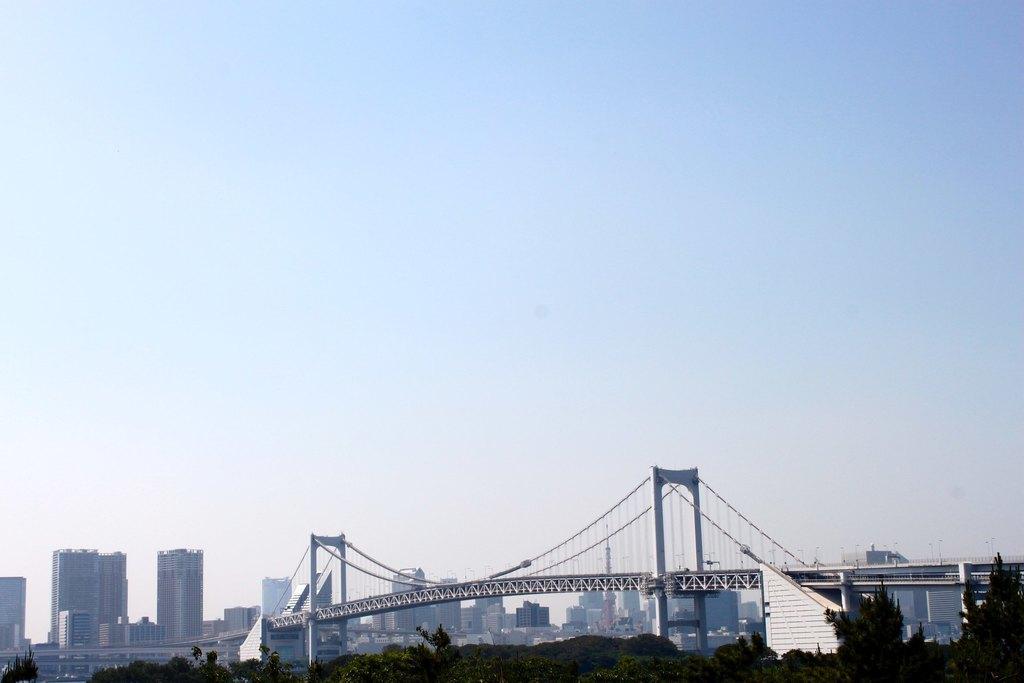Could you give a brief overview of what you see in this image? In this image we can see there are trees, bridge, river, buildings and the sky. 